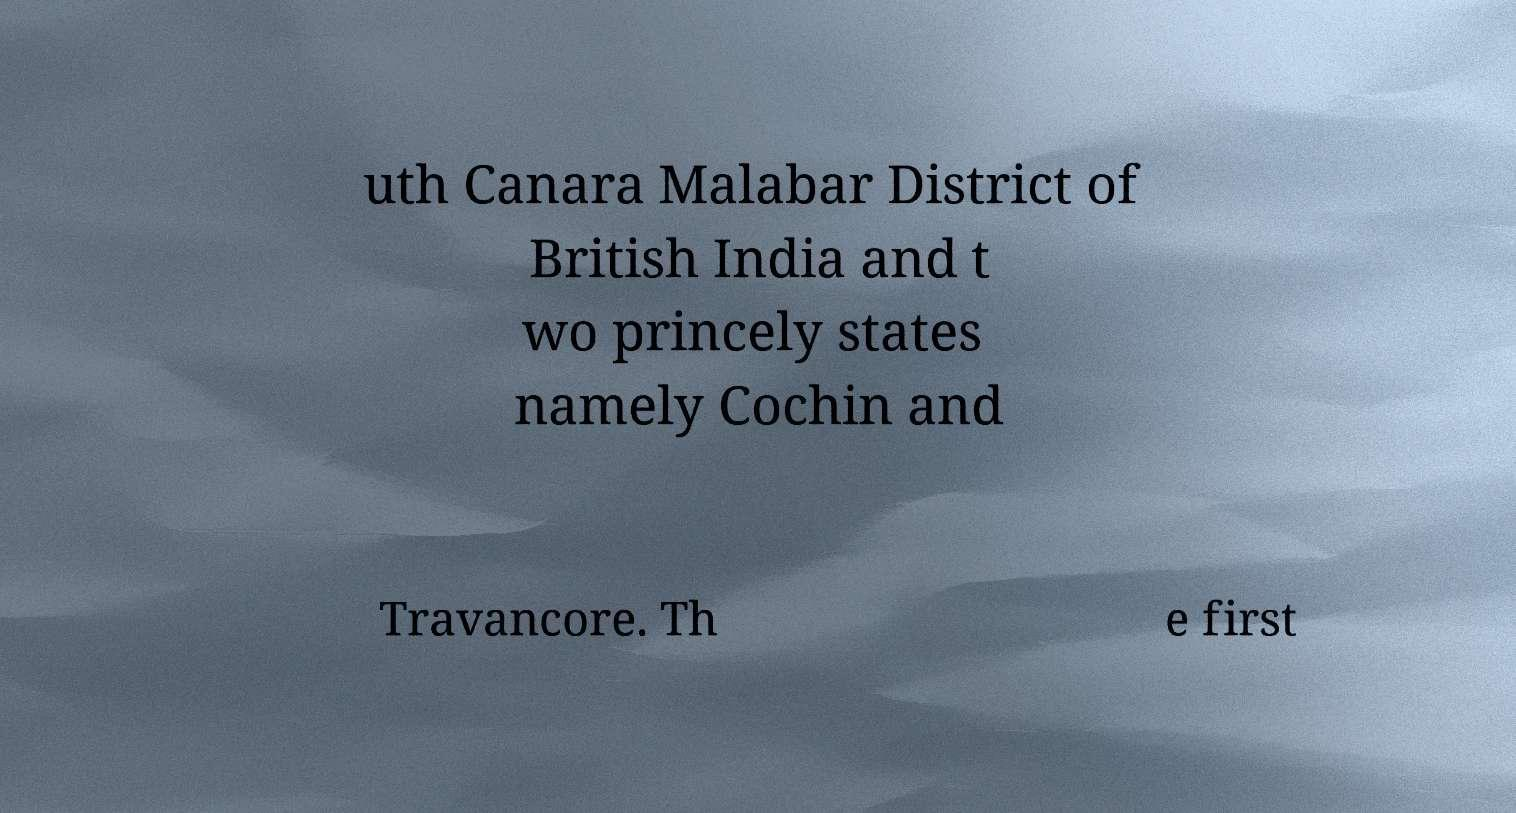Please read and relay the text visible in this image. What does it say? uth Canara Malabar District of British India and t wo princely states namely Cochin and Travancore. Th e first 